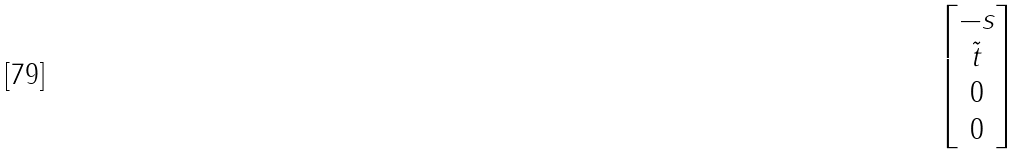Convert formula to latex. <formula><loc_0><loc_0><loc_500><loc_500>\begin{bmatrix} - s \\ \tilde { t } \\ 0 \\ 0 \end{bmatrix}</formula> 